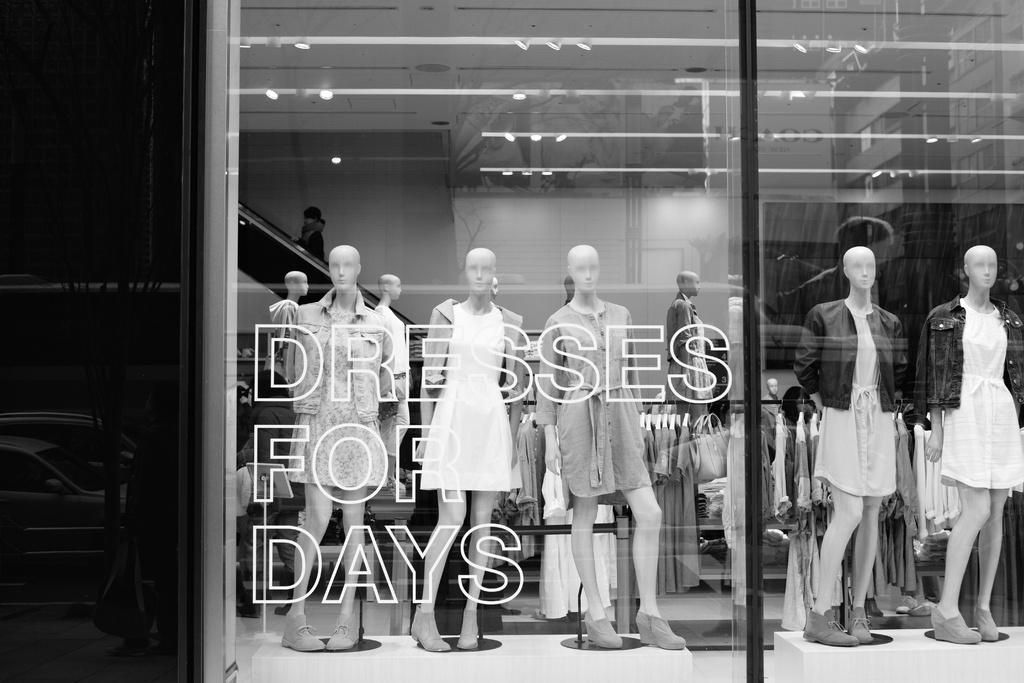What type of objects can be seen in the image? There are mannequins in the image. What are the mannequins wearing? There are clothes in the image. What can be seen on the ceiling in the image? There are lights on the ceiling in the image. What type of wall is present in the image? There is a glass wall in the image. What is written on the glass wall? Something is written on the glass wall. What color scheme is used in the image? The image is black and white in color. How does the image convey the concept of war? The image does not convey the concept of war, as it features mannequins, clothes, lights, a glass wall, and written text in a black and white color scheme. 